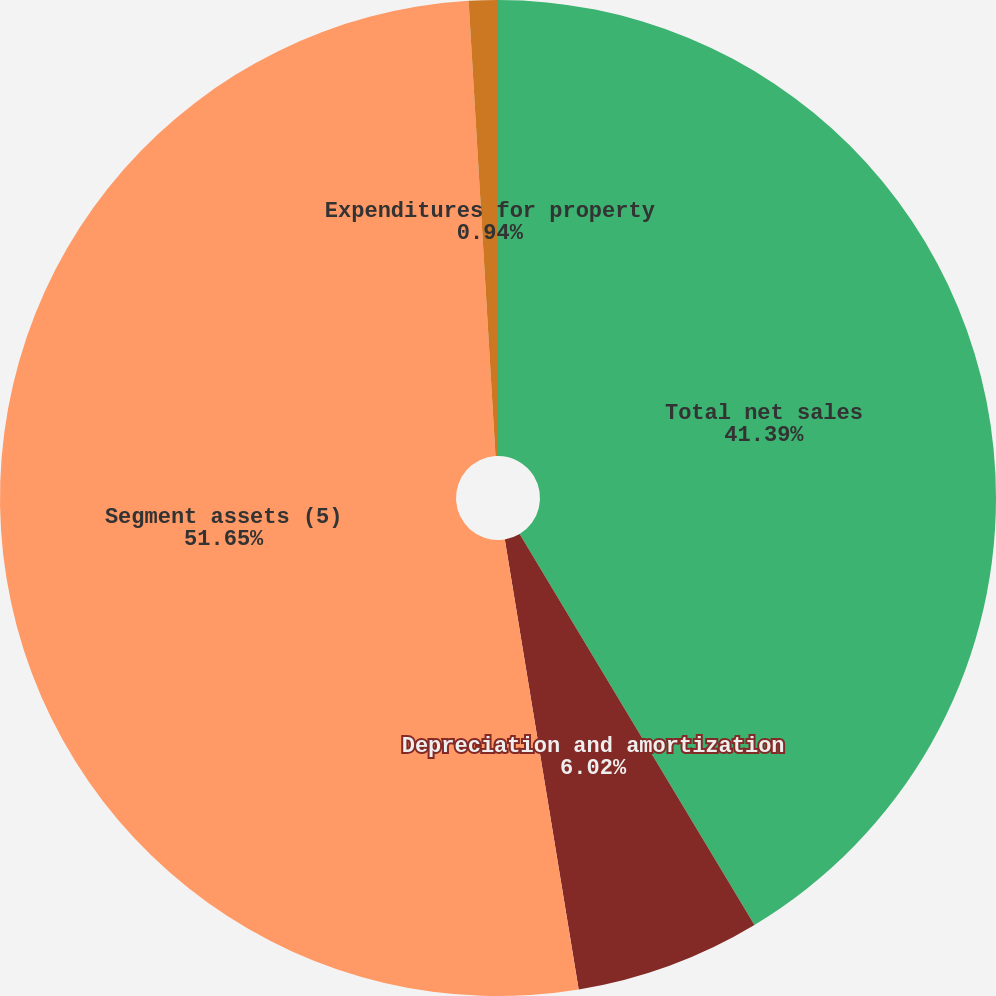<chart> <loc_0><loc_0><loc_500><loc_500><pie_chart><fcel>Total net sales<fcel>Depreciation and amortization<fcel>Segment assets (5)<fcel>Expenditures for property<nl><fcel>41.39%<fcel>6.02%<fcel>51.65%<fcel>0.94%<nl></chart> 